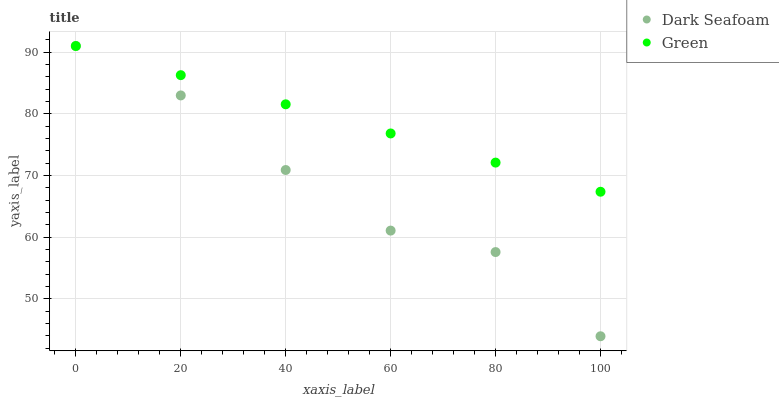Does Dark Seafoam have the minimum area under the curve?
Answer yes or no. Yes. Does Green have the maximum area under the curve?
Answer yes or no. Yes. Does Green have the minimum area under the curve?
Answer yes or no. No. Is Green the smoothest?
Answer yes or no. Yes. Is Dark Seafoam the roughest?
Answer yes or no. Yes. Is Green the roughest?
Answer yes or no. No. Does Dark Seafoam have the lowest value?
Answer yes or no. Yes. Does Green have the lowest value?
Answer yes or no. No. Does Green have the highest value?
Answer yes or no. Yes. Does Dark Seafoam intersect Green?
Answer yes or no. Yes. Is Dark Seafoam less than Green?
Answer yes or no. No. Is Dark Seafoam greater than Green?
Answer yes or no. No. 